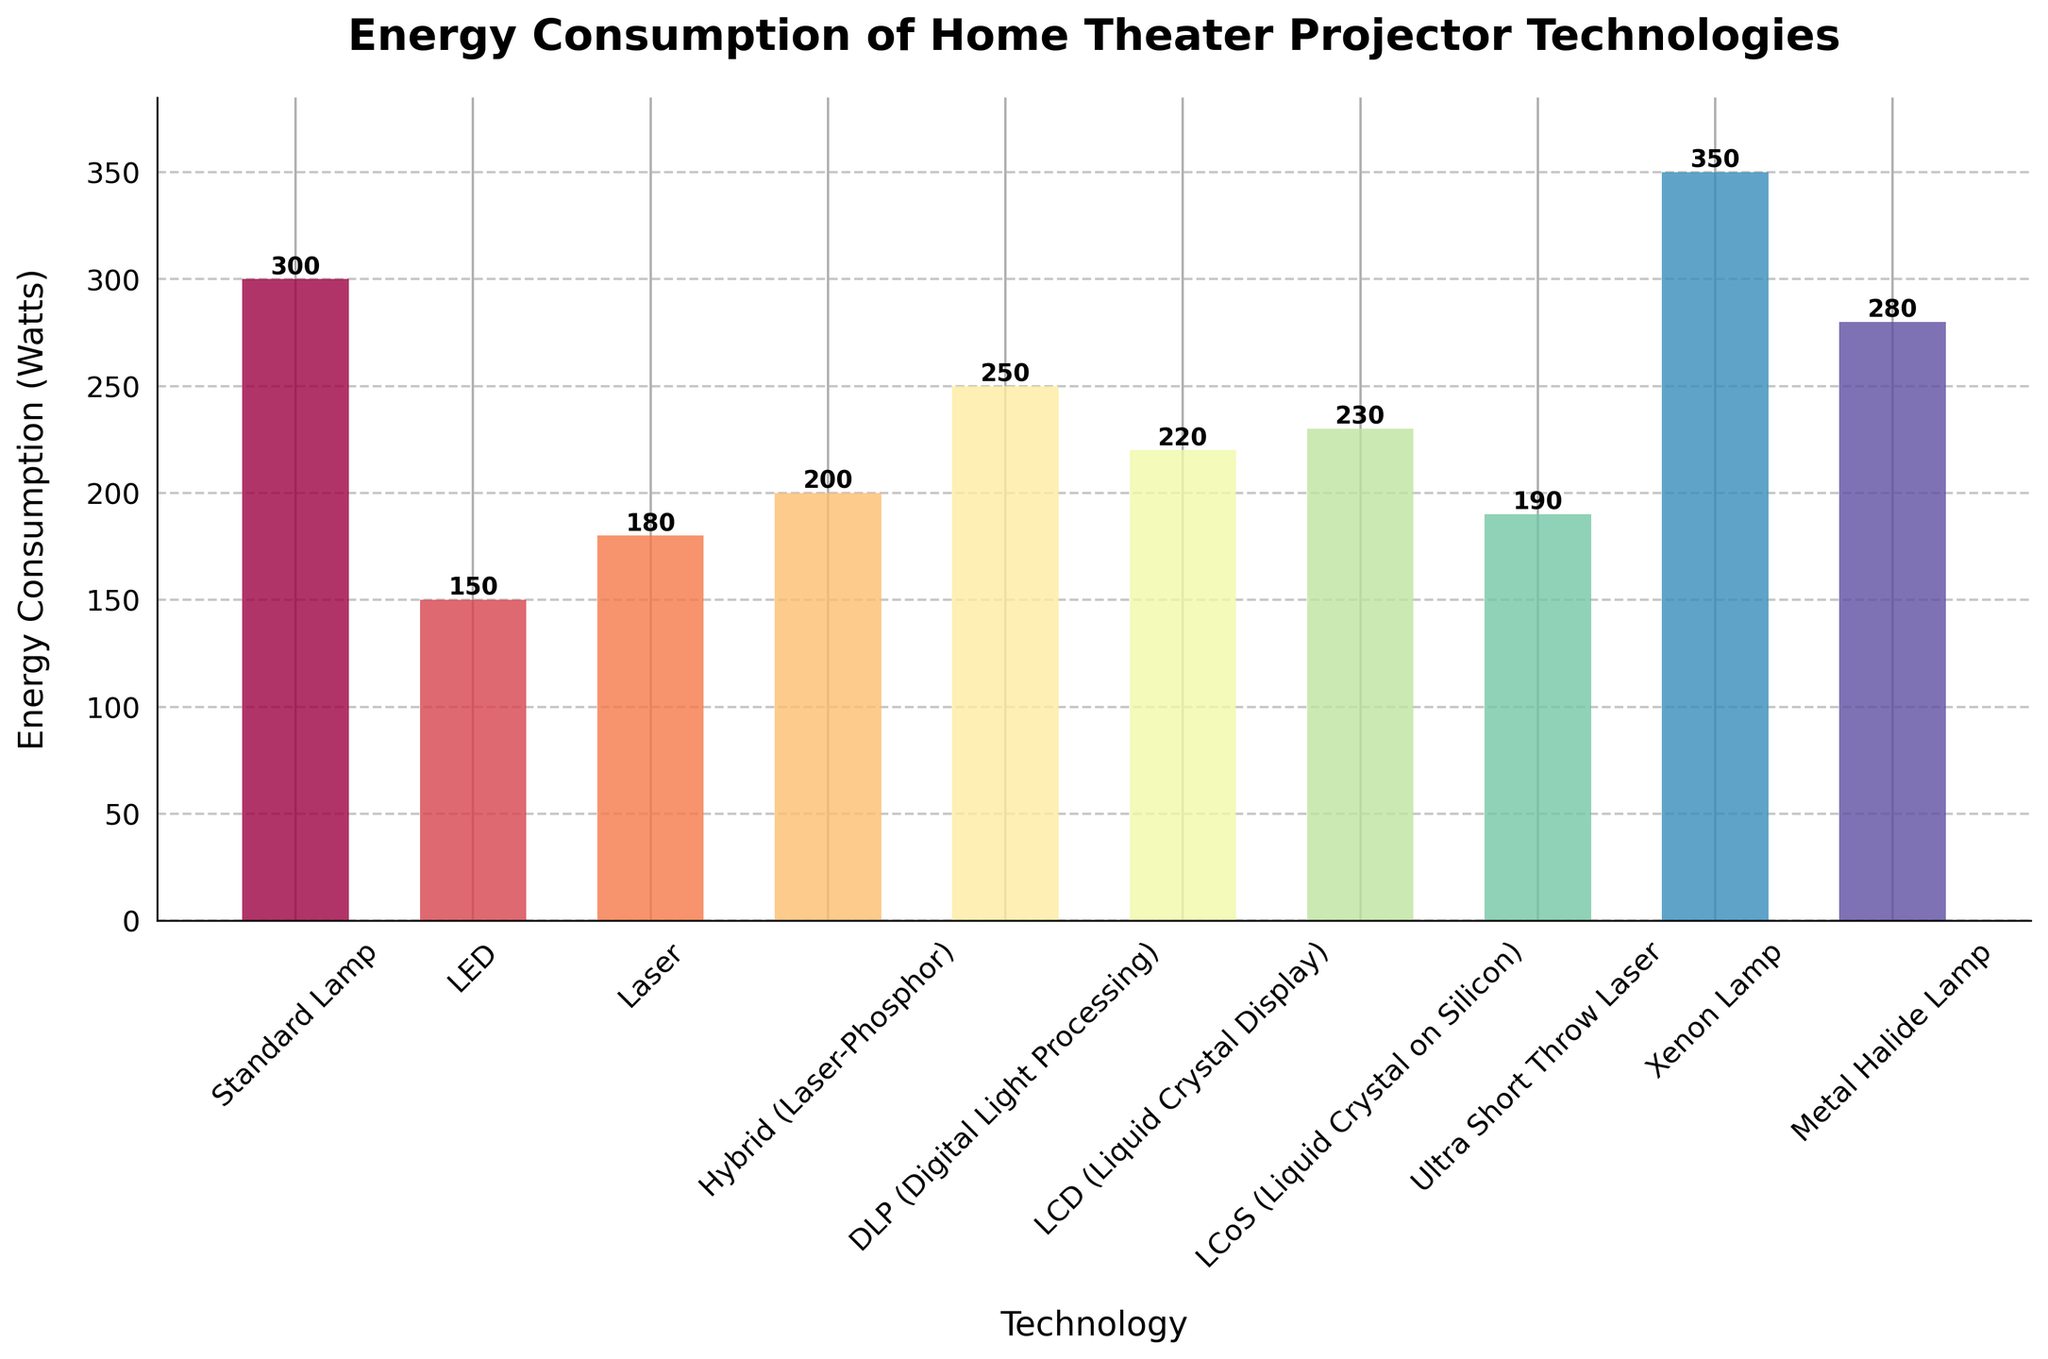What's the highest energy consumption among the projector technologies? The highest bar represents the technology with the highest energy consumption, which is Xenon Lamp at 350 Watts.
Answer: 350 Watts Which technology has the lowest energy consumption and how much is it? The shortest bar represents the technology with the lowest energy consumption, which is LED at 150 Watts.
Answer: LED at 150 Watts Which projector technology consumes more energy: Standard Lamp or Laser? Compare the height of the bars for Standard Lamp and Laser. Standard Lamp consumes 300 Watts, while Laser consumes 180 Watts.
Answer: Standard Lamp What's the total energy consumption of LED, Laser, and Hybrid (Laser-Phosphor)? Sum the energy consumption values for LED (150 Watts), Laser (180 Watts), and Hybrid (Laser-Phosphor) (200 Watts): 150 + 180 + 200 = 530 Watts.
Answer: 530 Watts Which technology falls between 200 Watts and 300 Watts in terms of energy consumption? Identify the bars that represent technologies with energy consumption between 200 and 300 Watts: Hybrid (Laser-Phosphor) at 200 Watts, DLP at 250 Watts, LCD at 220 Watts, and LCoS at 230 Watts.
Answer: Hybrid (Laser-Phosphor), DLP, LCD, LCoS How much more energy does the Xenon Lamp consume compared to the LED? Subtract the energy consumption of LED (150 Watts) from Xenon Lamp (350 Watts): 350 - 150 = 200 Watts.
Answer: 200 Watts What’s the average energy consumption of all listed projector technologies? Sum all energy consumption values and divide by the number of technologies: (300 + 150 + 180 + 200 + 250 + 220 + 230 + 190 + 350 + 280)/10 = 2350/10 = 235 Watts.
Answer: 235 Watts Which two technologies have energy consumptions closest to each other? Compare the difference in energy consumption between each technology pair. Hybrid (Laser-Phosphor) at 200 Watts and Ultra Short Throw Laser at 190 Watts have the smallest difference of 10 Watts.
Answer: Hybrid (Laser-Phosphor) and Ultra Short Throw Laser 